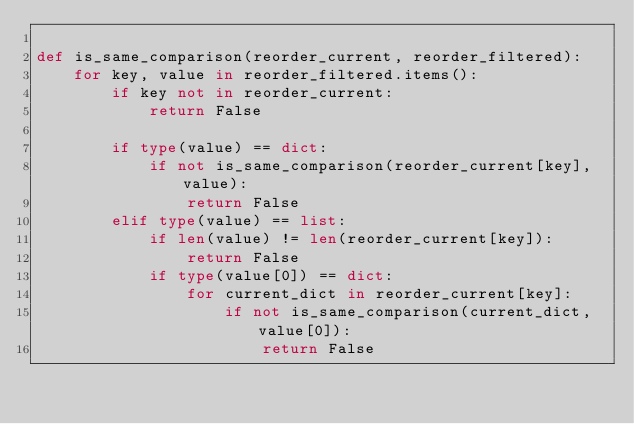<code> <loc_0><loc_0><loc_500><loc_500><_Python_>
def is_same_comparison(reorder_current, reorder_filtered):
    for key, value in reorder_filtered.items():
        if key not in reorder_current:
            return False

        if type(value) == dict:
            if not is_same_comparison(reorder_current[key], value):
                return False
        elif type(value) == list:
            if len(value) != len(reorder_current[key]):
                return False
            if type(value[0]) == dict:
                for current_dict in reorder_current[key]:
                    if not is_same_comparison(current_dict, value[0]):
                        return False</code> 